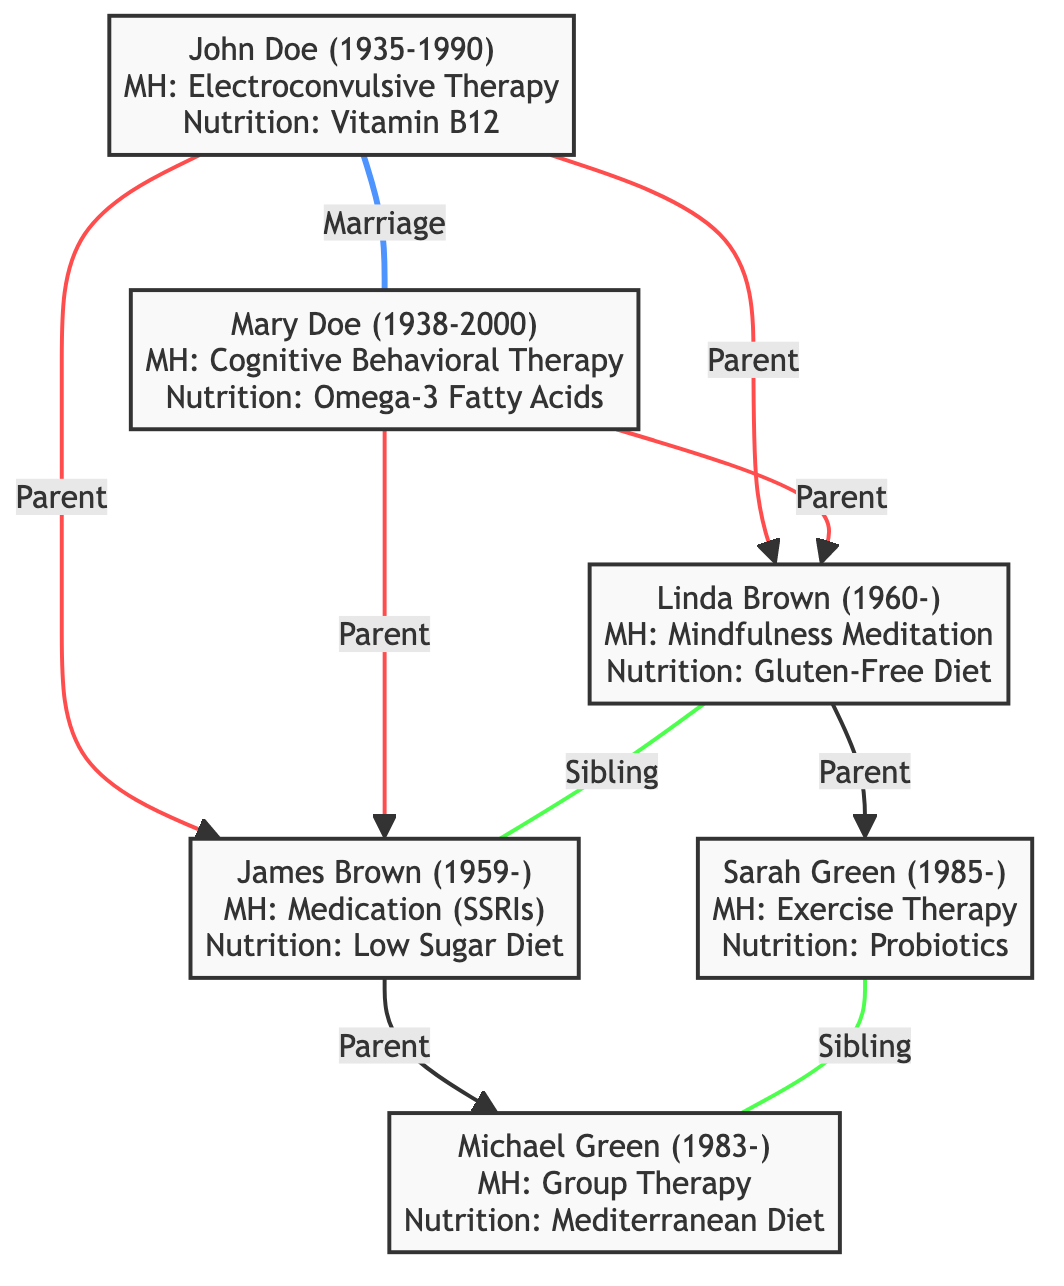What is the birth year of John Doe? The birth year is specified for John Doe in the diagram as 1935.
Answer: 1935 Who underwent Cognitive Behavioral Therapy? The diagram indicates that Mary Doe received Cognitive Behavioral Therapy as her mental health intervention.
Answer: Mary Doe How many children did John and Mary Doe have? John and Mary Doe have two children, Linda Brown and James Brown, mentioned in the diagram.
Answer: 2 Which nutritional intervention did Linda Brown follow? According to the diagram, Linda Brown followed a Gluten-Free Diet as her nutritional intervention.
Answer: Gluten-Free Diet What is the relationship between Linda Brown and James Brown? The diagram shows that Linda Brown and James Brown are siblings, which is indicated by the sibling connection between them.
Answer: Siblings What year was Sarah Green born? The birth year of Sarah Green is specified in the diagram as 1985.
Answer: 1985 How many mental health interventions involved therapy in the family? In the diagram, the mental health interventions that involved therapy are Electroconvulsive Therapy, Cognitive Behavioral Therapy, Mindfulness Meditation, Exercise Therapy, and Group Therapy, making a total of five.
Answer: 5 Which family member was diagnosed with bipolar disorder? The diagram reveals that James Brown was diagnosed with bipolar disorder, as mentioned in his notes.
Answer: James Brown What type of diet did Michael Green follow? According to the diagram, Michael Green followed a Mediterranean Diet for his nutritional intervention.
Answer: Mediterranean Diet 